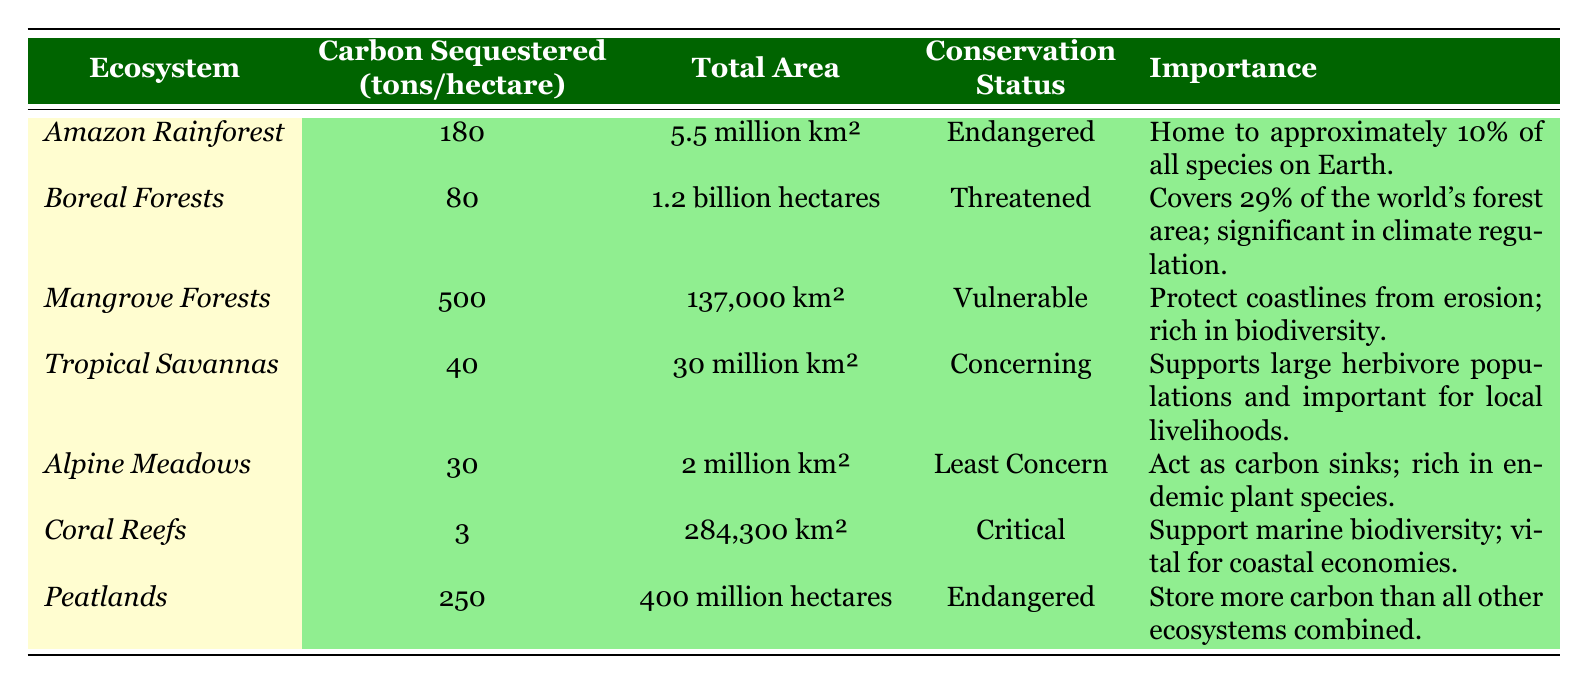What is the total area of the Amazon Rainforest? The table lists the total area for the Amazon Rainforest as 5.5 million km².
Answer: 5.5 million km² How much carbon is sequestered per hectare in Mangrove Forests? According to the table, Mangrove Forests sequester 500 tons of carbon per hectare.
Answer: 500 tons Which ecosystem has the highest carbon sequestration per hectare? By comparing the 'carbon sequestered per hectare' values, Mangrove Forests have the highest at 500 tons.
Answer: Mangrove Forests What is the conservation status of Coral Reefs? The table indicates that the conservation status of Coral Reefs is Critical.
Answer: Critical How many tons of carbon do Boreal Forests sequester per hectare compared to Tropical Savannas? Boreal Forests sequester 80 tons per hectare, while Tropical Savannas sequester 40 tons; hence, Boreal Forests sequester 40 tons more.
Answer: 40 tons Which ecosystem has the least amount of carbon sequestered per hectare? The table shows that Coral Reefs sequester only 3 tons per hectare, which is the least among the listed ecosystems.
Answer: Coral Reefs What is the total area of Peatlands in hectares? The table states that Peatlands cover a total area of 400 million hectares.
Answer: 400 million hectares Which ecosystem covers the largest area and what is its conservation status? Tropical Savannas cover the largest area at 30 million km², and their conservation status is concerning.
Answer: 30 million km², concerning If we sum the carbon sequestration potentials of Alpine Meadows and Tropical Savannas, what is the total? Alpine Meadows sequester 30 tons and Tropical Savannas sequester 40 tons, so 30 + 40 = 70 tons combined.
Answer: 70 tons Is the Amazon Rainforest considered endangered or vulnerable? The table indicates that the conservation status of the Amazon Rainforest is Endangered.
Answer: Endangered Which ecosystems are classified as Endangered? The table shows that the Amazon Rainforest and Peatlands are both classified as Endangered.
Answer: Amazon Rainforest, Peatlands What ecosystem is most beneficial for coastal protection? According to the table, Mangrove Forests are identified as beneficial for coastal protection by preventing erosion.
Answer: Mangrove Forests If you compare the total area of Boreal Forests and the Amazon Rainforest, which one is larger? Boreal Forests cover 1.2 billion hectares (approximately 12 million km²), while the Amazon Rainforest covers 5.5 million km². Therefore, Boreal Forests are larger.
Answer: Boreal Forests How much carbon do Peatlands store compared to Coral Reefs in tons per hectare? Peatlands sequester 250 tons per hectare, while Coral Reefs sequester 3 tons. The difference is 247 tons more for Peatlands.
Answer: 247 tons more What is the importance of Boreal Forests according to the data? The table details that Boreal Forests cover 29% of the world's forest area and are significant in climate regulation.
Answer: Significant in climate regulation 